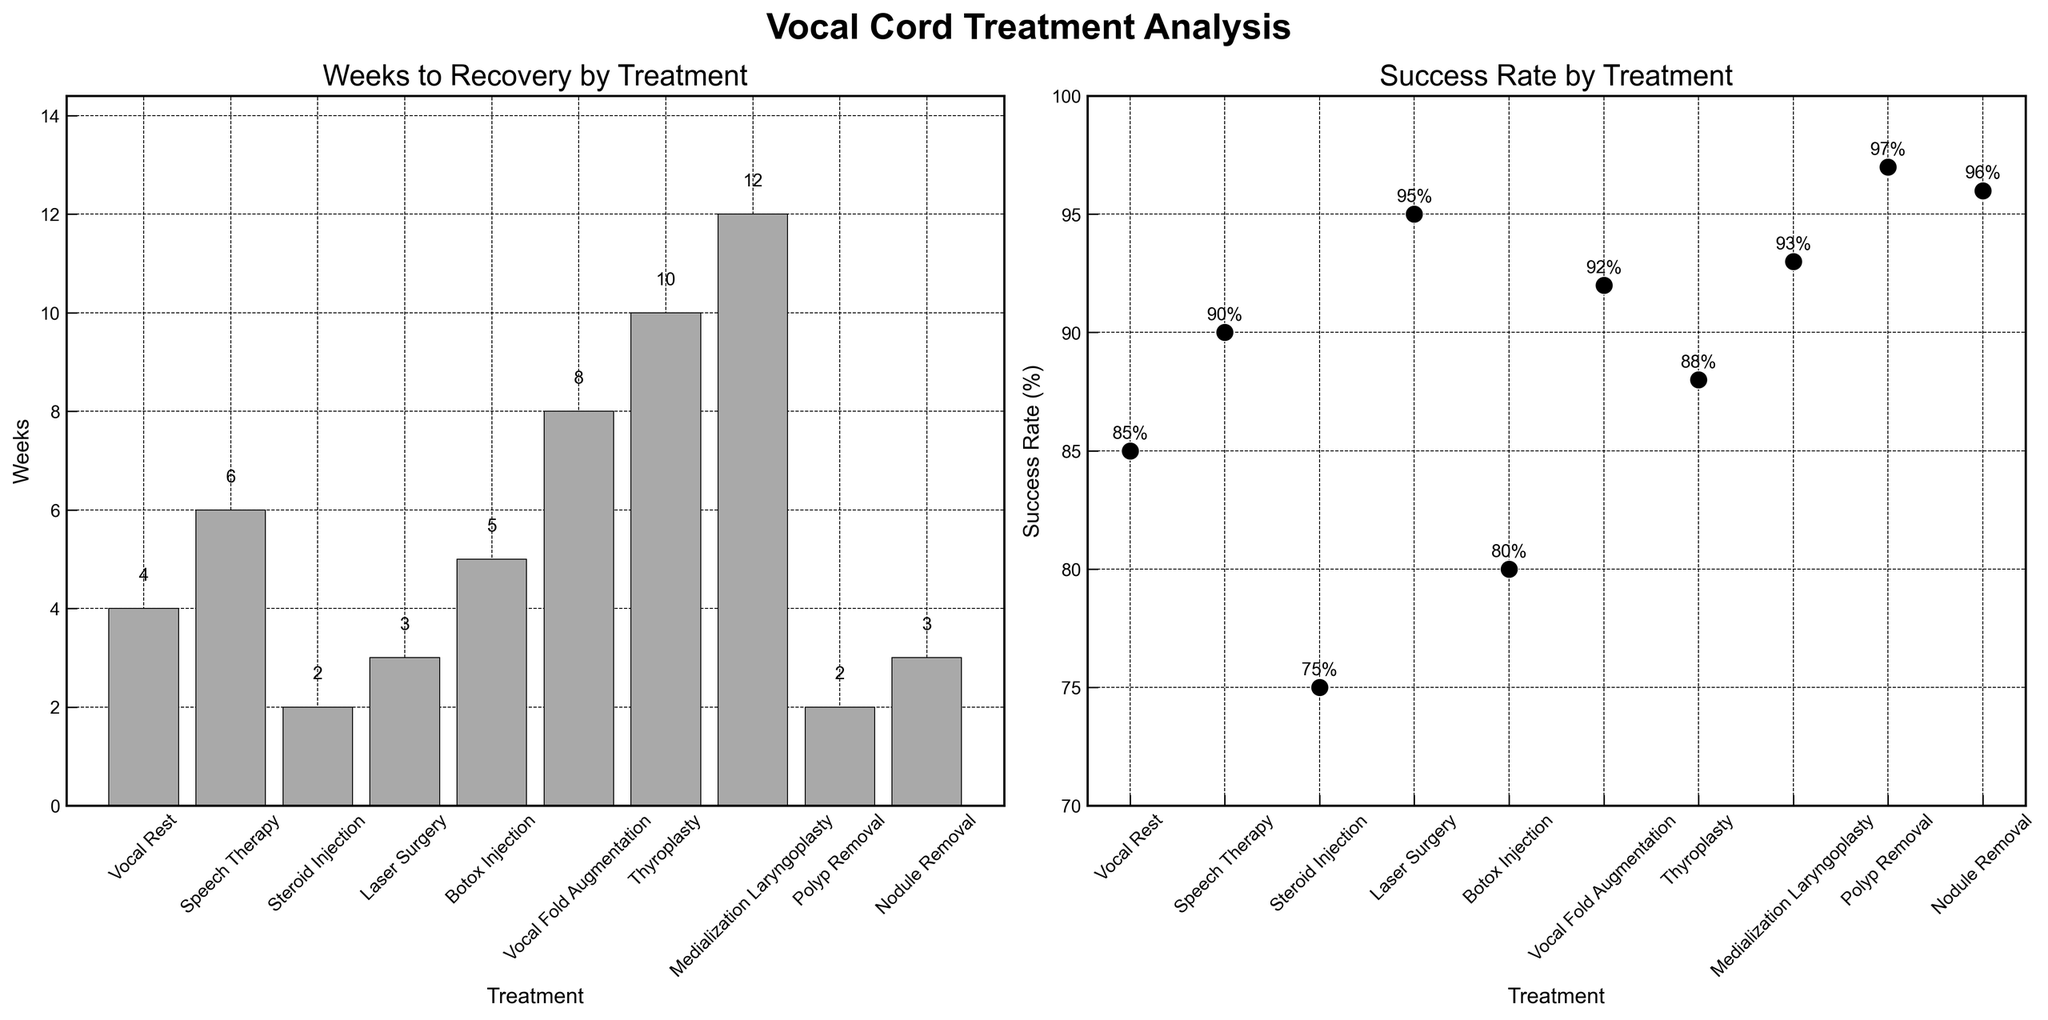How many treatments are analyzed in the figure? The figure includes all treatments listed on the x-axis of both subplots. By counting them, we can see that there are 10 treatments analyzed in the figure.
Answer: 10 Which treatment has the shortest recovery time? By comparing the heights of the bars in the "Weeks to Recovery by Treatment" subplot, we see that Polyp Removal and Steroid Injection have the shortest recovery time of 2 weeks.
Answer: Polyp Removal, Steroid Injection What is the success rate for the treatment with the longest recovery time? The longest recovery time shown in the "Weeks to Recovery by Treatment" subplot is for Medialization Laryngoplasty, with 12 weeks. According to the "Success Rate by Treatment" subplot, the success rate for this treatment is 93%.
Answer: 93% Which treatment has the highest success rate and how many weeks does it take for recovery? In the "Success Rate by Treatment" subplot, the highest success rate is 97%, which is associated with Polyp Removal. In the "Weeks to Recovery by Treatment" subplot, Polyp Removal has a recovery time of 2 weeks.
Answer: Polyp Removal, 2 weeks Compare the weeks to recovery between Speech Therapy and Botox Injection. In the "Weeks to Recovery by Treatment" subplot, Speech Therapy has a recovery time of 6 weeks while Botox Injection has a recovery time of 5 weeks. Therefore, Speech Therapy takes 1 week longer for recovery.
Answer: Speech Therapy takes 1 week longer Which treatment offers the highest success rate with less than or equal to 4 weeks of recovery time? We need to look at treatments with recovery times of 4 weeks or less and compare their success rates. Treatments with <= 4 weeks are Vocal Rest, Steroid Injection, Laser Surgery, Polyp Removal, and Nodule Removal, with success rates of 85%, 75%, 95%, 97%, and 96% respectively. Polyp Removal, with a success rate of 97%, is the highest among these.
Answer: Polyp Removal What is the average recovery time for treatments that have a success rate of 90% or above? We identify treatments with success rates of 90% or above: Speech Therapy (6 weeks), Laser Surgery (3 weeks), Vocal Fold Augmentation (8 weeks), Thyroplasty (10 weeks), Medialization Laryngoplasty (12 weeks), Polyp Removal (2 weeks), Nodule Removal (3 weeks). The total weeks are 6 + 3 + 8 + 10 + 12 + 2 + 3 = 44 weeks. There are 7 treatments. So, the average recovery time is 44/7 = 6.29 weeks.
Answer: 6.29 weeks Which treatment has the lowest success rate and what is its weeks to recovery? The treatment with the lowest success rate in the "Success Rate by Treatment" subplot is Steroid Injection with a rate of 75%. According to the "Weeks to Recovery by Treatment" subplot, its recovery time is 2 weeks.
Answer: Steroid Injection, 2 weeks How does the recovery time of Thyroplasty compare with that of Vocal Fold Augmentation? From the "Weeks to Recovery by Treatment" subplot, Thyroplasty has a recovery time of 10 weeks, while Vocal Fold Augmentation has a recovery time of 8 weeks. Thus, Thyroplasty takes 2 weeks longer than Vocal Fold Augmentation.
Answer: Thyroplasty takes 2 weeks longer 